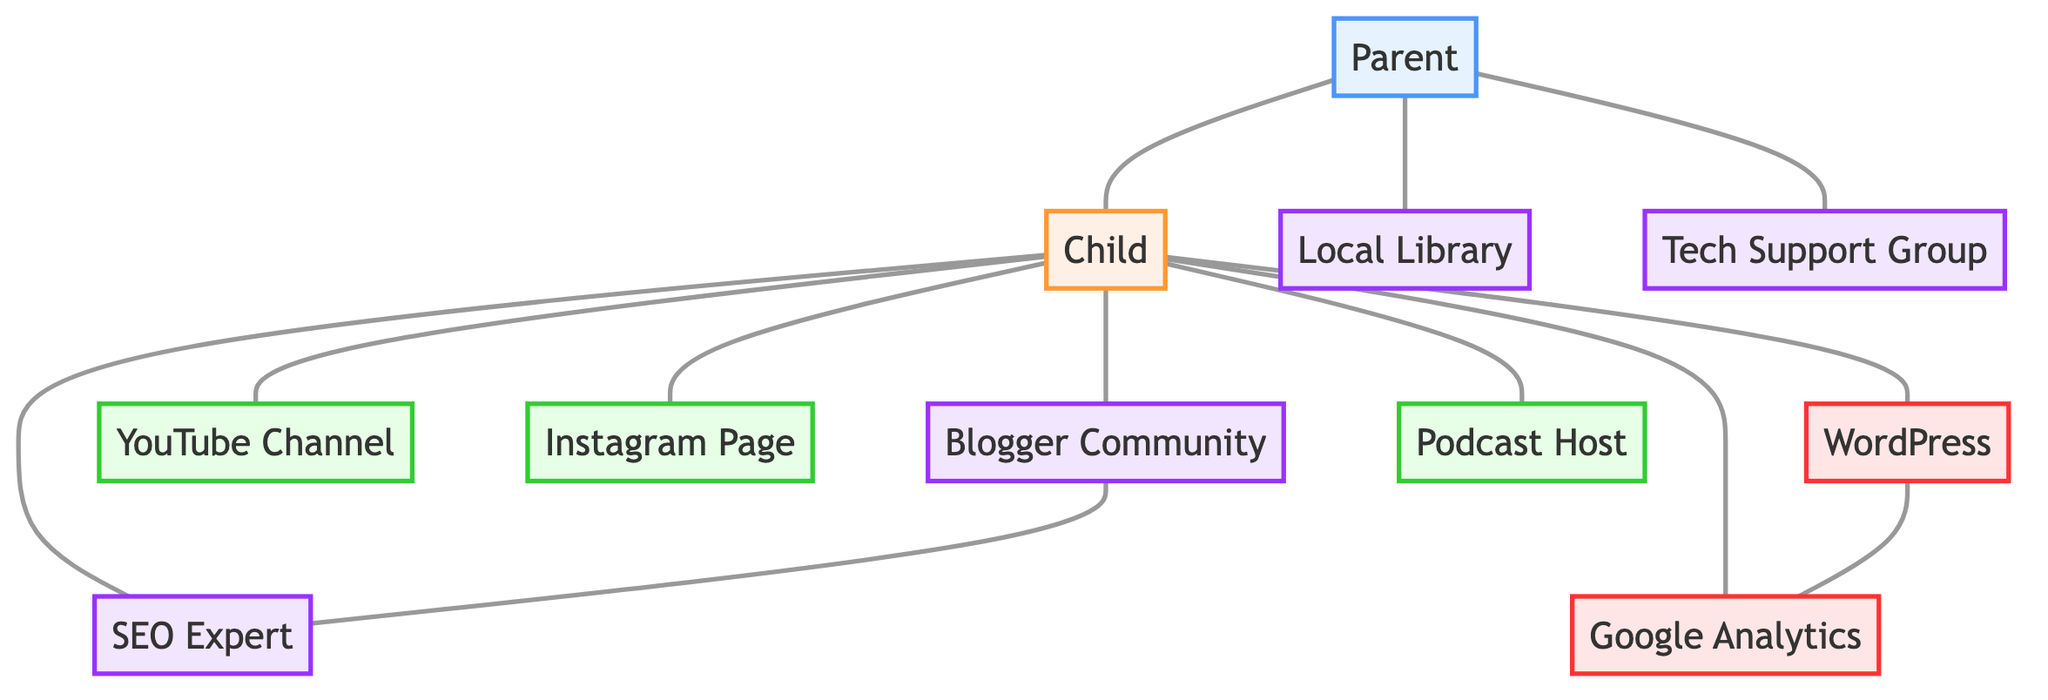What is the total number of nodes in the diagram? By counting each unique item in the nodes section of the data, we find there are 11 distinct nodes.
Answer: 11 Which node is directly connected to the Child node? The edges section shows that the Child node connects to Blogger Community, YouTube Channel, Instagram Page, WordPress, Google Analytics, SEO Expert, and Podcast Host, making it a total of 7 direct connections.
Answer: 7 How many support nodes are present in the diagram? I examine the nodes labeled as support: Blogger Community, SEO Expert, Local Library, and Tech Support Group. In total, there are 4 nodes classified as support.
Answer: 4 What platforms does the Child connect to? The platforms that the Child connects to, as seen in the edges, include YouTube Channel, Instagram Page, WordPress, and Podcast Host, giving a total of 4 platforms.
Answer: 4 Is there a direct connection between the Parent and SEO Expert? The edges indicate that the Parent node does not connect directly to the SEO Expert, as there is no edge listed between these two nodes in the diagram.
Answer: No Which node connects Blogger Community and SEO Expert? The connection between Blogger Community and SEO Expert is established directly, as indicated in the edges section of the data.
Answer: SEO Expert What type of tool is Google Analytics classified as? The diagram categorizes Google Analytics as a tool, according to the classification defined in the provided code.
Answer: Tool Which node has a connection with both WordPress and Google Analytics? The WordPress node has an edge that connects it directly to the Google Analytics node, confirming a relationship between these two.
Answer: WordPress What is the relationship between the Parent and Tech Support Group? The diagram shows a direct connection (an edge) between the Parent and the Tech Support Group, indicating the Parent seeks support from this group.
Answer: Direct connection How many edges are there connecting nodes in the diagram? By counting each edge listed in the edges section of the data, we find a total of 11 edges that represent the various relationships among the nodes.
Answer: 11 